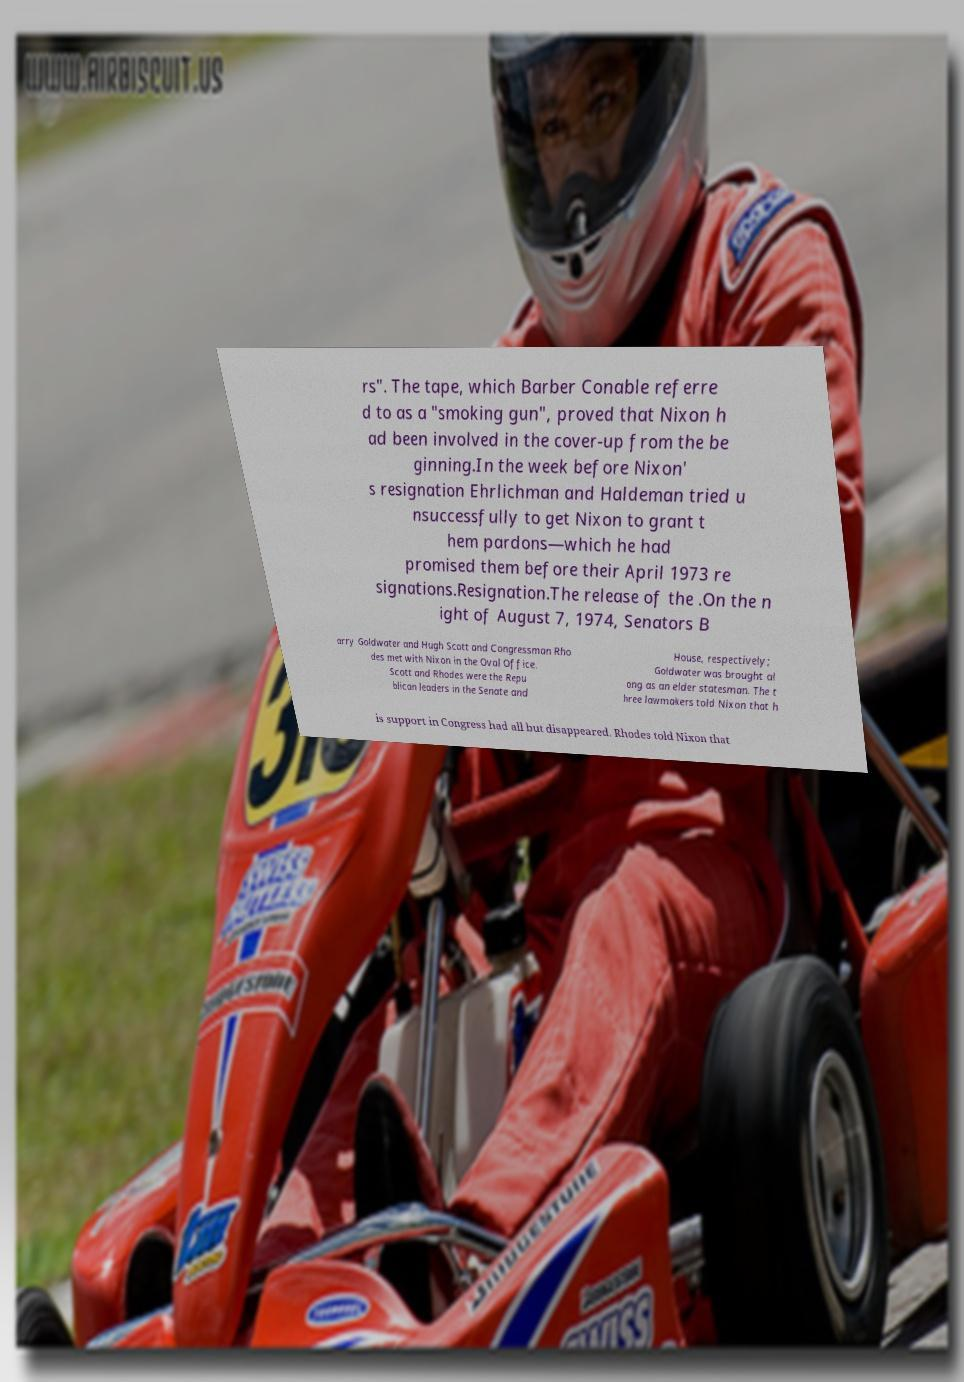For documentation purposes, I need the text within this image transcribed. Could you provide that? rs". The tape, which Barber Conable referre d to as a "smoking gun", proved that Nixon h ad been involved in the cover-up from the be ginning.In the week before Nixon' s resignation Ehrlichman and Haldeman tried u nsuccessfully to get Nixon to grant t hem pardons—which he had promised them before their April 1973 re signations.Resignation.The release of the .On the n ight of August 7, 1974, Senators B arry Goldwater and Hugh Scott and Congressman Rho des met with Nixon in the Oval Office. Scott and Rhodes were the Repu blican leaders in the Senate and House, respectively; Goldwater was brought al ong as an elder statesman. The t hree lawmakers told Nixon that h is support in Congress had all but disappeared. Rhodes told Nixon that 